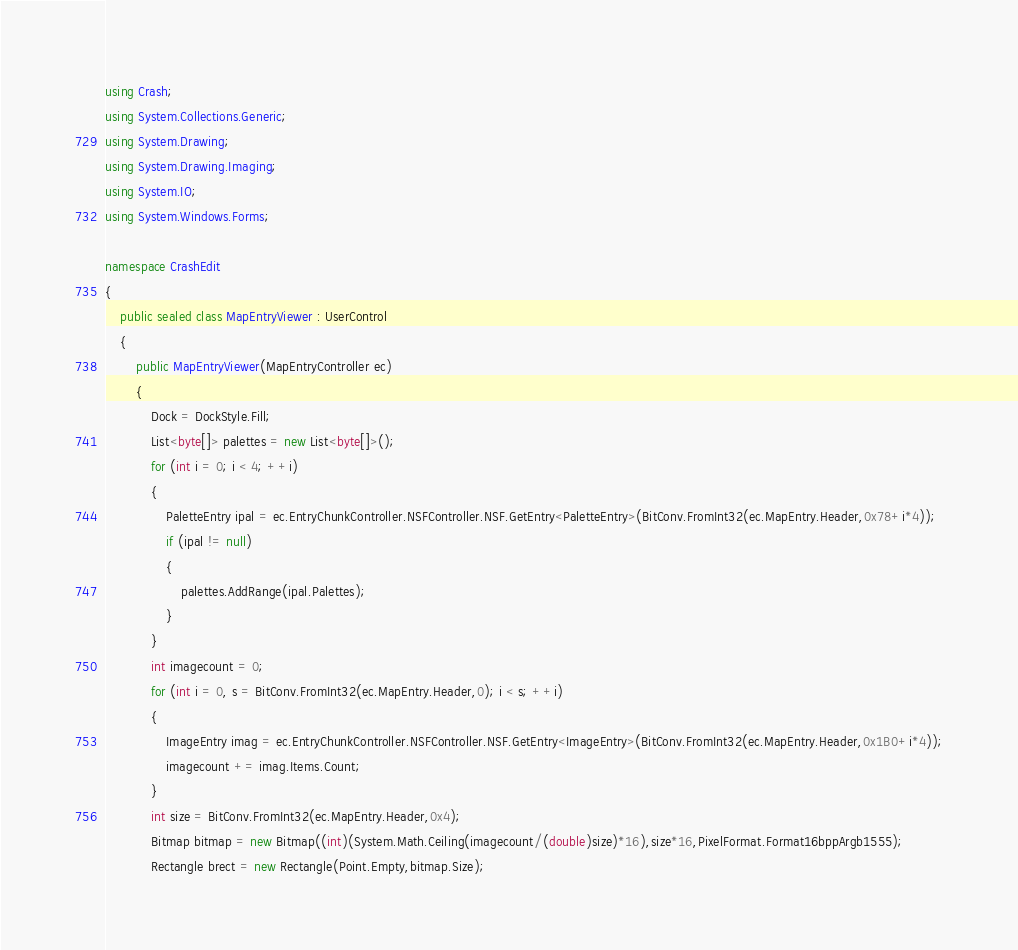<code> <loc_0><loc_0><loc_500><loc_500><_C#_>using Crash;
using System.Collections.Generic;
using System.Drawing;
using System.Drawing.Imaging;
using System.IO;
using System.Windows.Forms;

namespace CrashEdit
{
    public sealed class MapEntryViewer : UserControl
    {
        public MapEntryViewer(MapEntryController ec)
        {
            Dock = DockStyle.Fill;
            List<byte[]> palettes = new List<byte[]>();
            for (int i = 0; i < 4; ++i)
            {
                PaletteEntry ipal = ec.EntryChunkController.NSFController.NSF.GetEntry<PaletteEntry>(BitConv.FromInt32(ec.MapEntry.Header,0x78+i*4));
                if (ipal != null)
                {
                    palettes.AddRange(ipal.Palettes);
                }
            }
            int imagecount = 0;
            for (int i = 0, s = BitConv.FromInt32(ec.MapEntry.Header,0); i < s; ++i)
            {
                ImageEntry imag = ec.EntryChunkController.NSFController.NSF.GetEntry<ImageEntry>(BitConv.FromInt32(ec.MapEntry.Header,0x1B0+i*4));
                imagecount += imag.Items.Count;
            }
            int size = BitConv.FromInt32(ec.MapEntry.Header,0x4);
            Bitmap bitmap = new Bitmap((int)(System.Math.Ceiling(imagecount/(double)size)*16),size*16,PixelFormat.Format16bppArgb1555);
            Rectangle brect = new Rectangle(Point.Empty,bitmap.Size);</code> 